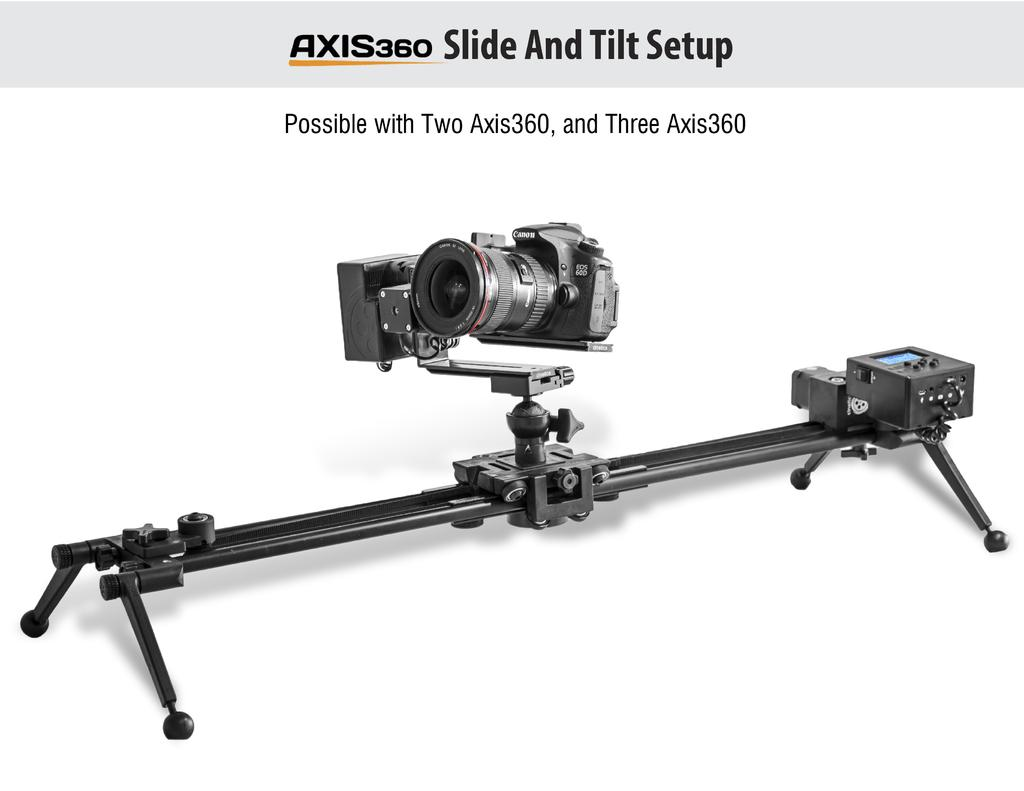What is the main object in the image? There is a camera in the image. How is the camera positioned in the image? The camera has a stand in the image. What color is the background of the image? The background of the image is white. What can be seen at the top of the image? There is text visible at the top of the image. How many rocks can be seen in the image? There are no rocks present in the image. Is the camera making any noise in the image? The image is static, so it does not depict any sound or noise. 